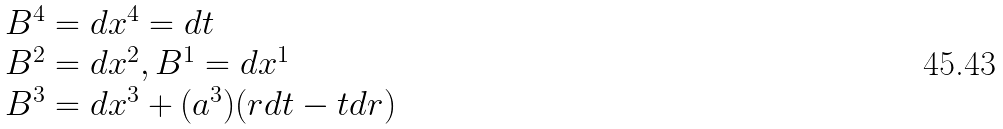<formula> <loc_0><loc_0><loc_500><loc_500>\begin{array} { l l l } B ^ { 4 } = d x ^ { 4 } = d t \\ B ^ { 2 } = d x ^ { 2 } , B ^ { 1 } = d x ^ { 1 } \\ B ^ { 3 } = d x ^ { 3 } + ( a ^ { 3 } ) ( r d t - t d r ) \\ \end{array}</formula> 